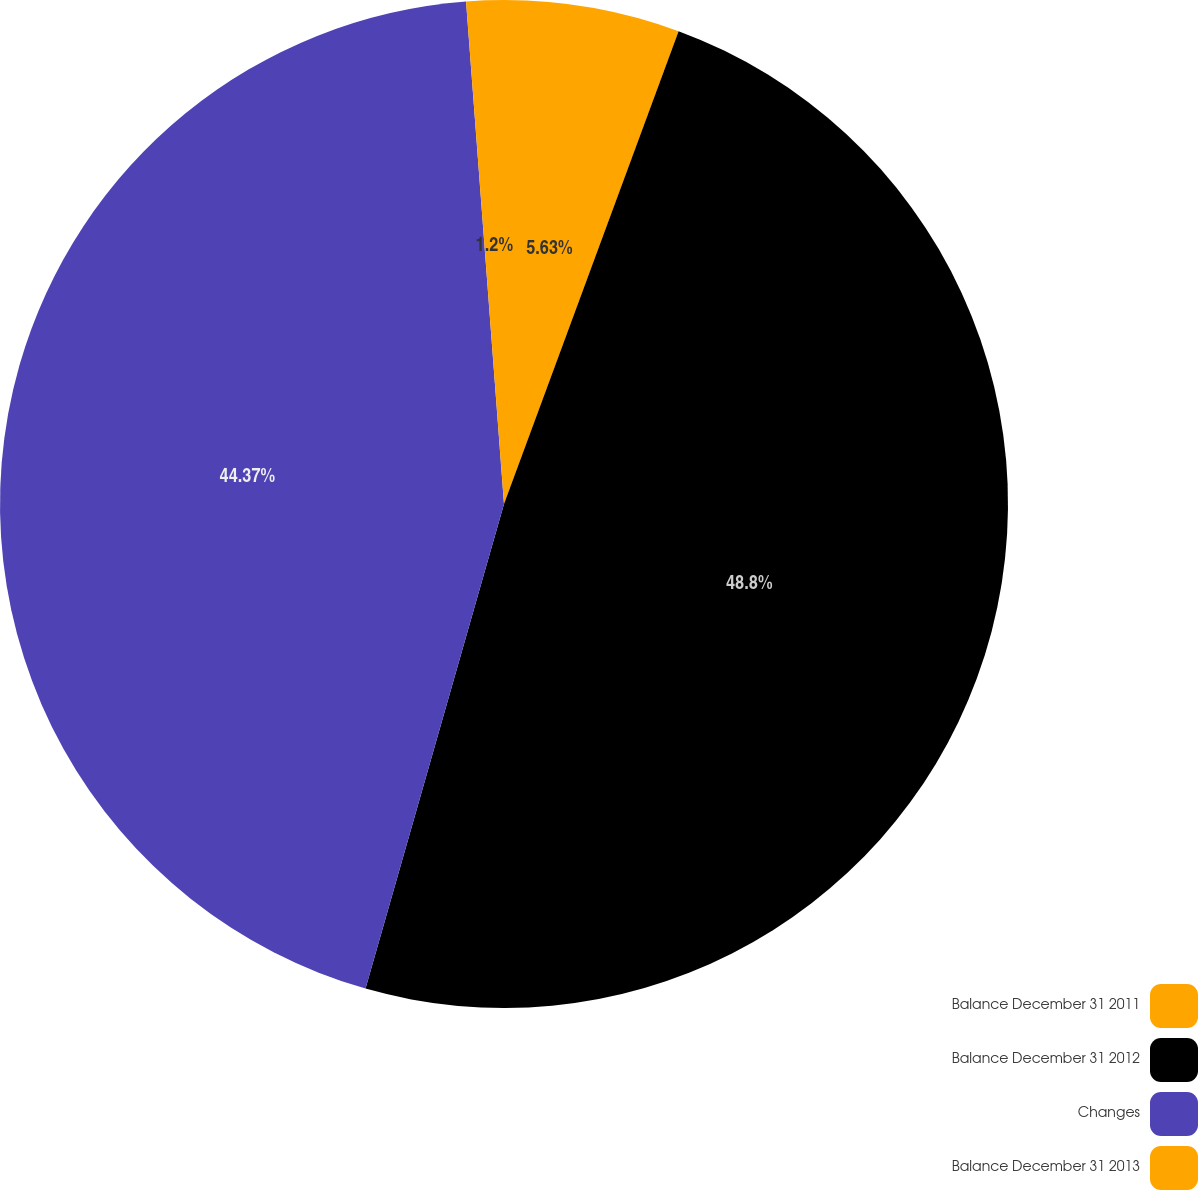<chart> <loc_0><loc_0><loc_500><loc_500><pie_chart><fcel>Balance December 31 2011<fcel>Balance December 31 2012<fcel>Changes<fcel>Balance December 31 2013<nl><fcel>5.63%<fcel>48.8%<fcel>44.37%<fcel>1.2%<nl></chart> 